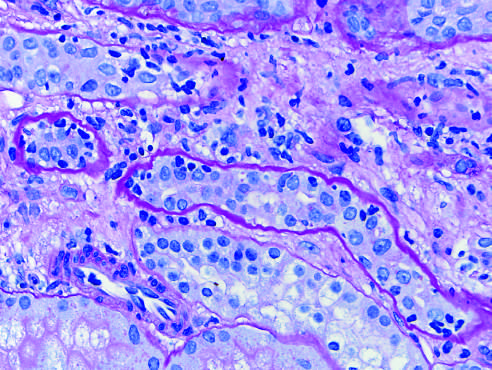what is acute cellular rejection of a kidney graft manifested by in the inter-stitium and between epithelial cells of the tubules tubulitis?
Answer the question using a single word or phrase. Inflammatory cells in the inter-stitium and between epithelial cells of the tubules tubulitis 